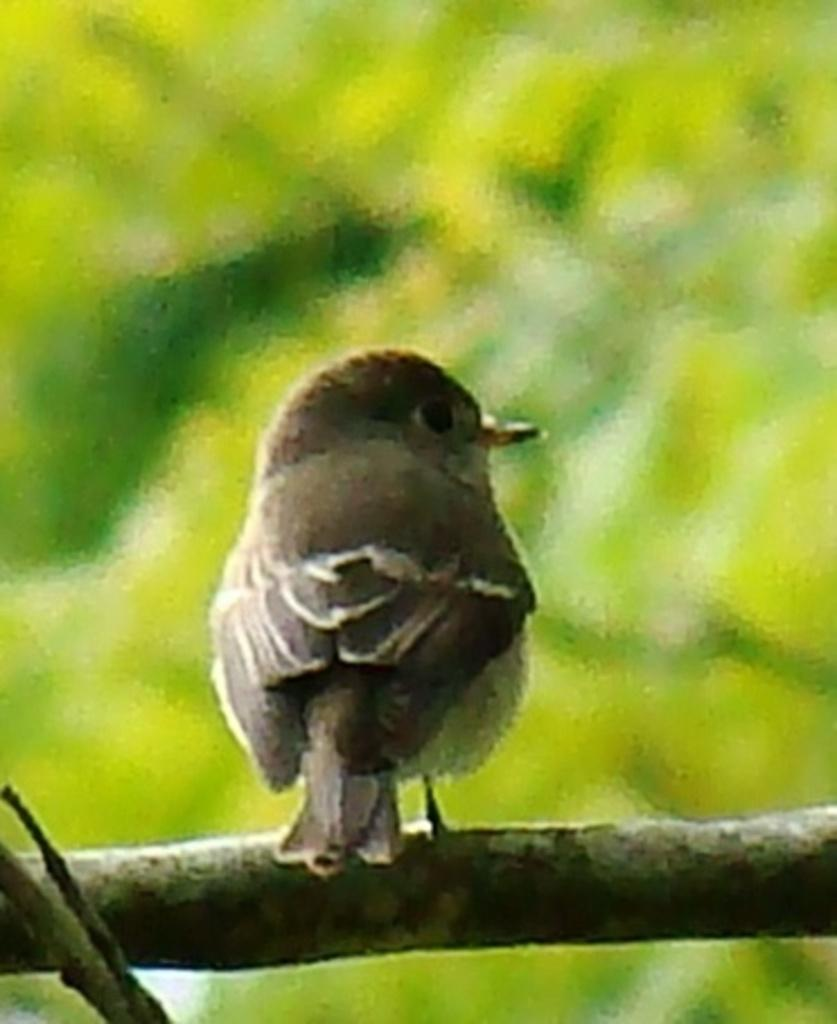What is the main subject of the image? There is a bird in the center of the image. Where is the bird located? The bird is on the bark. What color is the background of the image? The background of the image is green in color. What type of cord is the bird using to climb the bark? There is no cord present in the image, and the bird is not climbing the bark. 